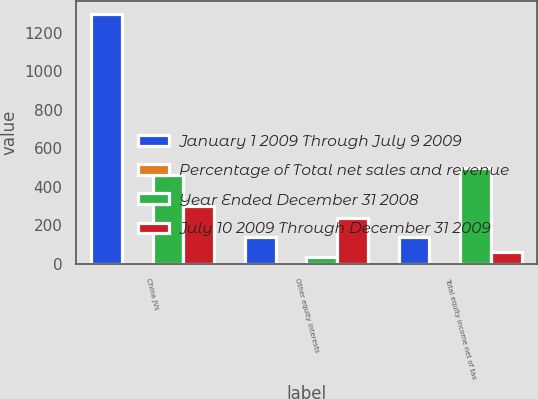Convert chart to OTSL. <chart><loc_0><loc_0><loc_500><loc_500><stacked_bar_chart><ecel><fcel>China JVs<fcel>Other equity interests<fcel>Total equity income net of tax<nl><fcel>January 1 2009 Through July 9 2009<fcel>1297<fcel>141<fcel>141<nl><fcel>Percentage of Total net sales and revenue<fcel>1<fcel>0.1<fcel>1.1<nl><fcel>Year Ended December 31 2008<fcel>460<fcel>37<fcel>497<nl><fcel>July 10 2009 Through December 31 2009<fcel>300<fcel>239<fcel>61<nl></chart> 